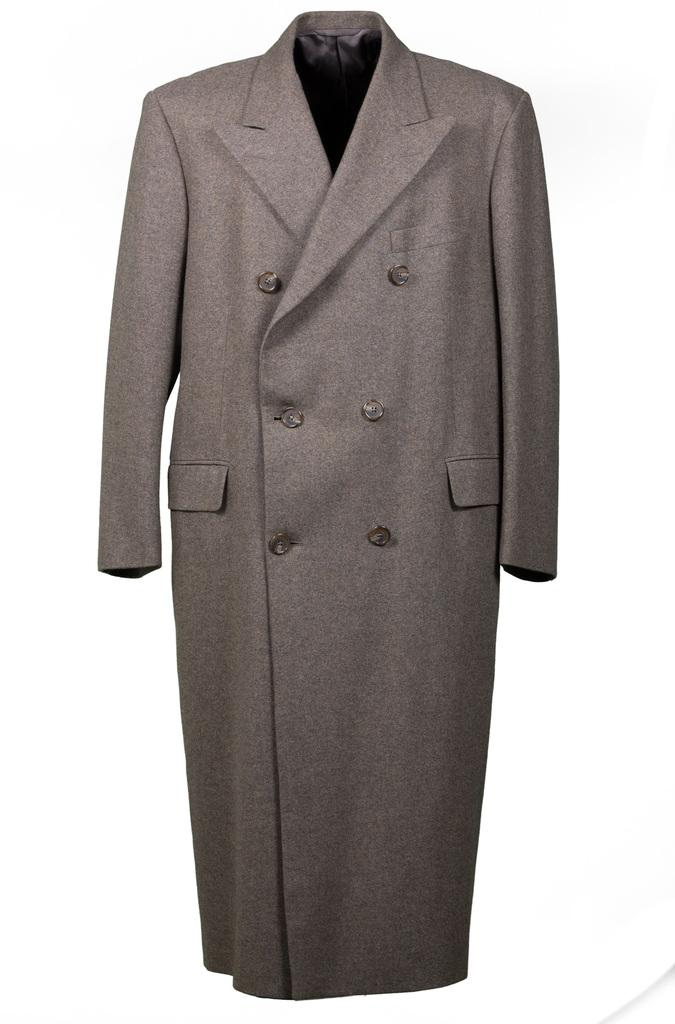What type of landscape can be seen in the image? There is a coast in the image. Can you describe the features of the coast? The coast features a shoreline and may include sand, rocks, or other natural elements. What type of environment is depicted in the image? The image depicts a coastal environment, which is characterized by the presence of water and land meeting. What type of stage can be seen in the image? There is no stage present in the image; it features a coast. Is there any connection between the coast and a laborer in the image? There is no laborer or any indication of labor-related activities in the image; it features a coast. 